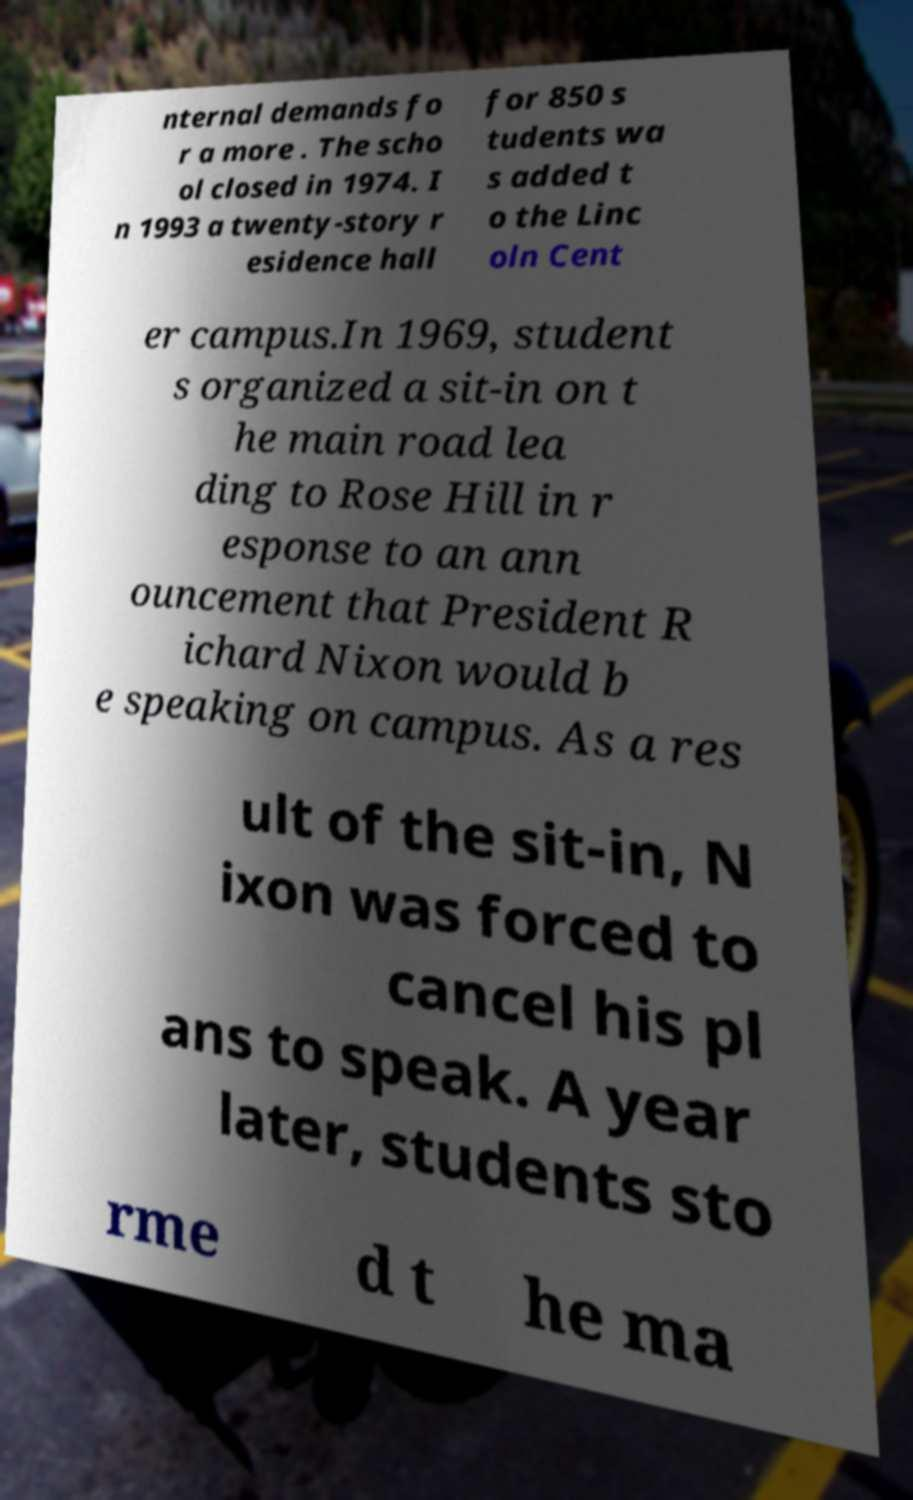Could you extract and type out the text from this image? nternal demands fo r a more . The scho ol closed in 1974. I n 1993 a twenty-story r esidence hall for 850 s tudents wa s added t o the Linc oln Cent er campus.In 1969, student s organized a sit-in on t he main road lea ding to Rose Hill in r esponse to an ann ouncement that President R ichard Nixon would b e speaking on campus. As a res ult of the sit-in, N ixon was forced to cancel his pl ans to speak. A year later, students sto rme d t he ma 